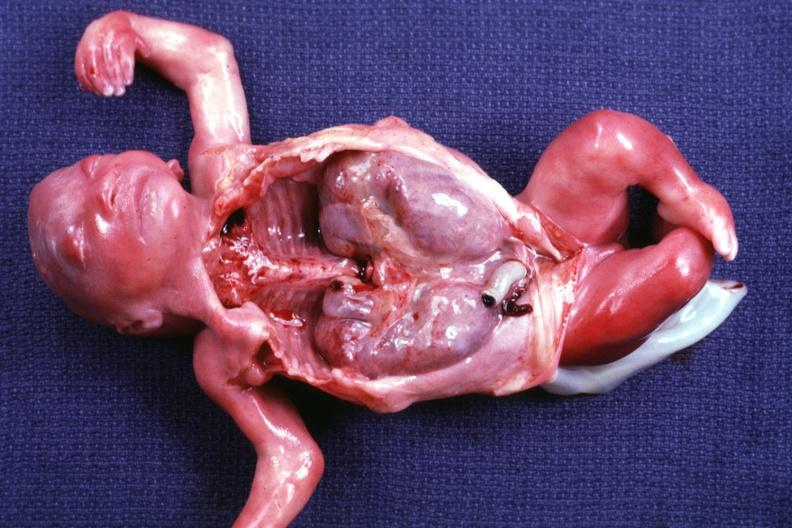s polycystic disease of kidneys present?
Answer the question using a single word or phrase. Yes 